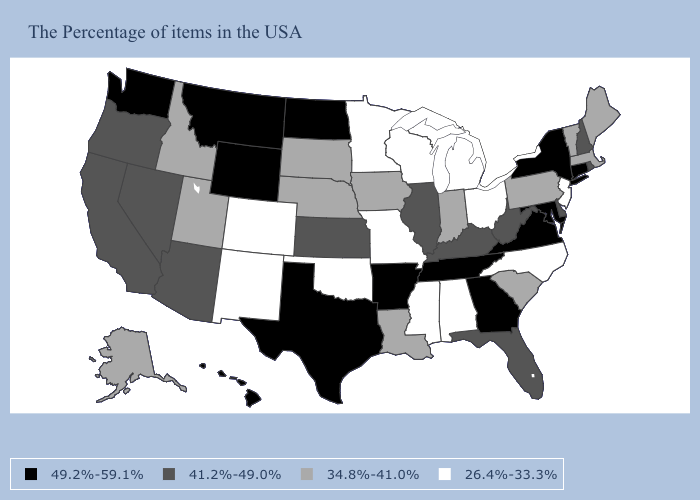Among the states that border Connecticut , which have the lowest value?
Short answer required. Massachusetts. Name the states that have a value in the range 34.8%-41.0%?
Give a very brief answer. Maine, Massachusetts, Vermont, Pennsylvania, South Carolina, Indiana, Louisiana, Iowa, Nebraska, South Dakota, Utah, Idaho, Alaska. Which states have the lowest value in the MidWest?
Be succinct. Ohio, Michigan, Wisconsin, Missouri, Minnesota. Which states hav the highest value in the South?
Answer briefly. Maryland, Virginia, Georgia, Tennessee, Arkansas, Texas. Which states have the lowest value in the MidWest?
Give a very brief answer. Ohio, Michigan, Wisconsin, Missouri, Minnesota. Does the map have missing data?
Keep it brief. No. Does Nevada have a higher value than Louisiana?
Concise answer only. Yes. Does Georgia have the highest value in the USA?
Give a very brief answer. Yes. What is the lowest value in states that border Texas?
Keep it brief. 26.4%-33.3%. Does Montana have the highest value in the West?
Give a very brief answer. Yes. Which states hav the highest value in the MidWest?
Keep it brief. North Dakota. Does New Hampshire have the highest value in the USA?
Concise answer only. No. What is the lowest value in states that border California?
Be succinct. 41.2%-49.0%. What is the value of Mississippi?
Answer briefly. 26.4%-33.3%. What is the value of Maine?
Write a very short answer. 34.8%-41.0%. 